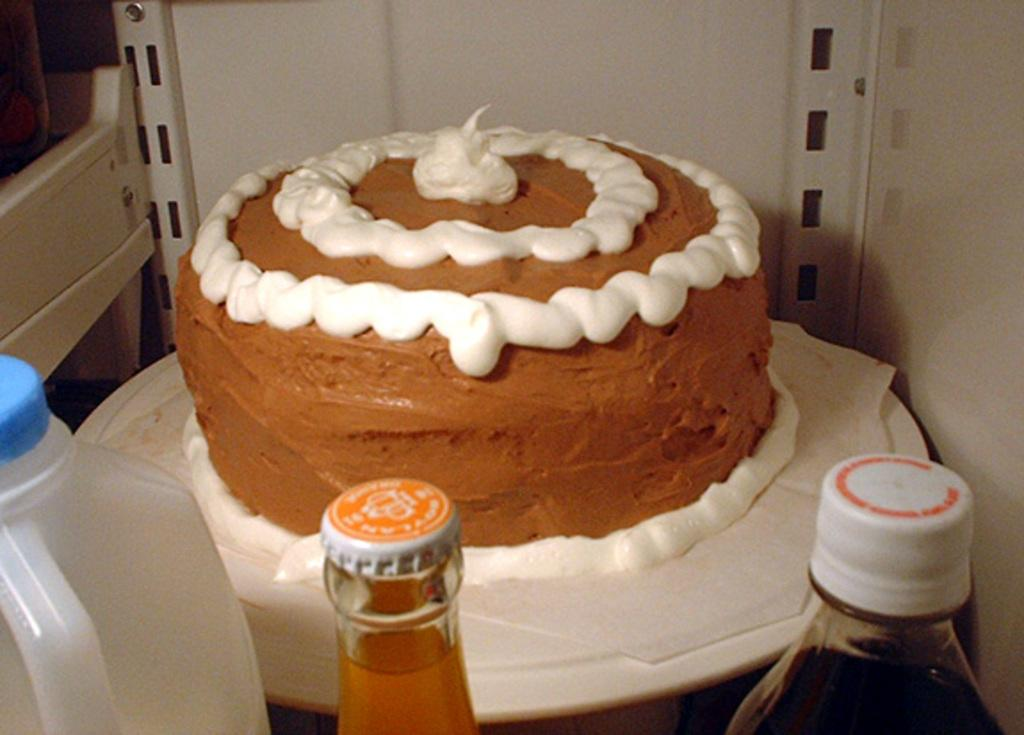What is the main subject of the image? There is a cake in the image. Can you describe the appearance of the cake? The cake has a white and brown color. How many bottles are visible in the image? There are 3 bottles in the image. What type of suit is the cake wearing in the image? There is no suit present in the image, as the subject is a cake. 